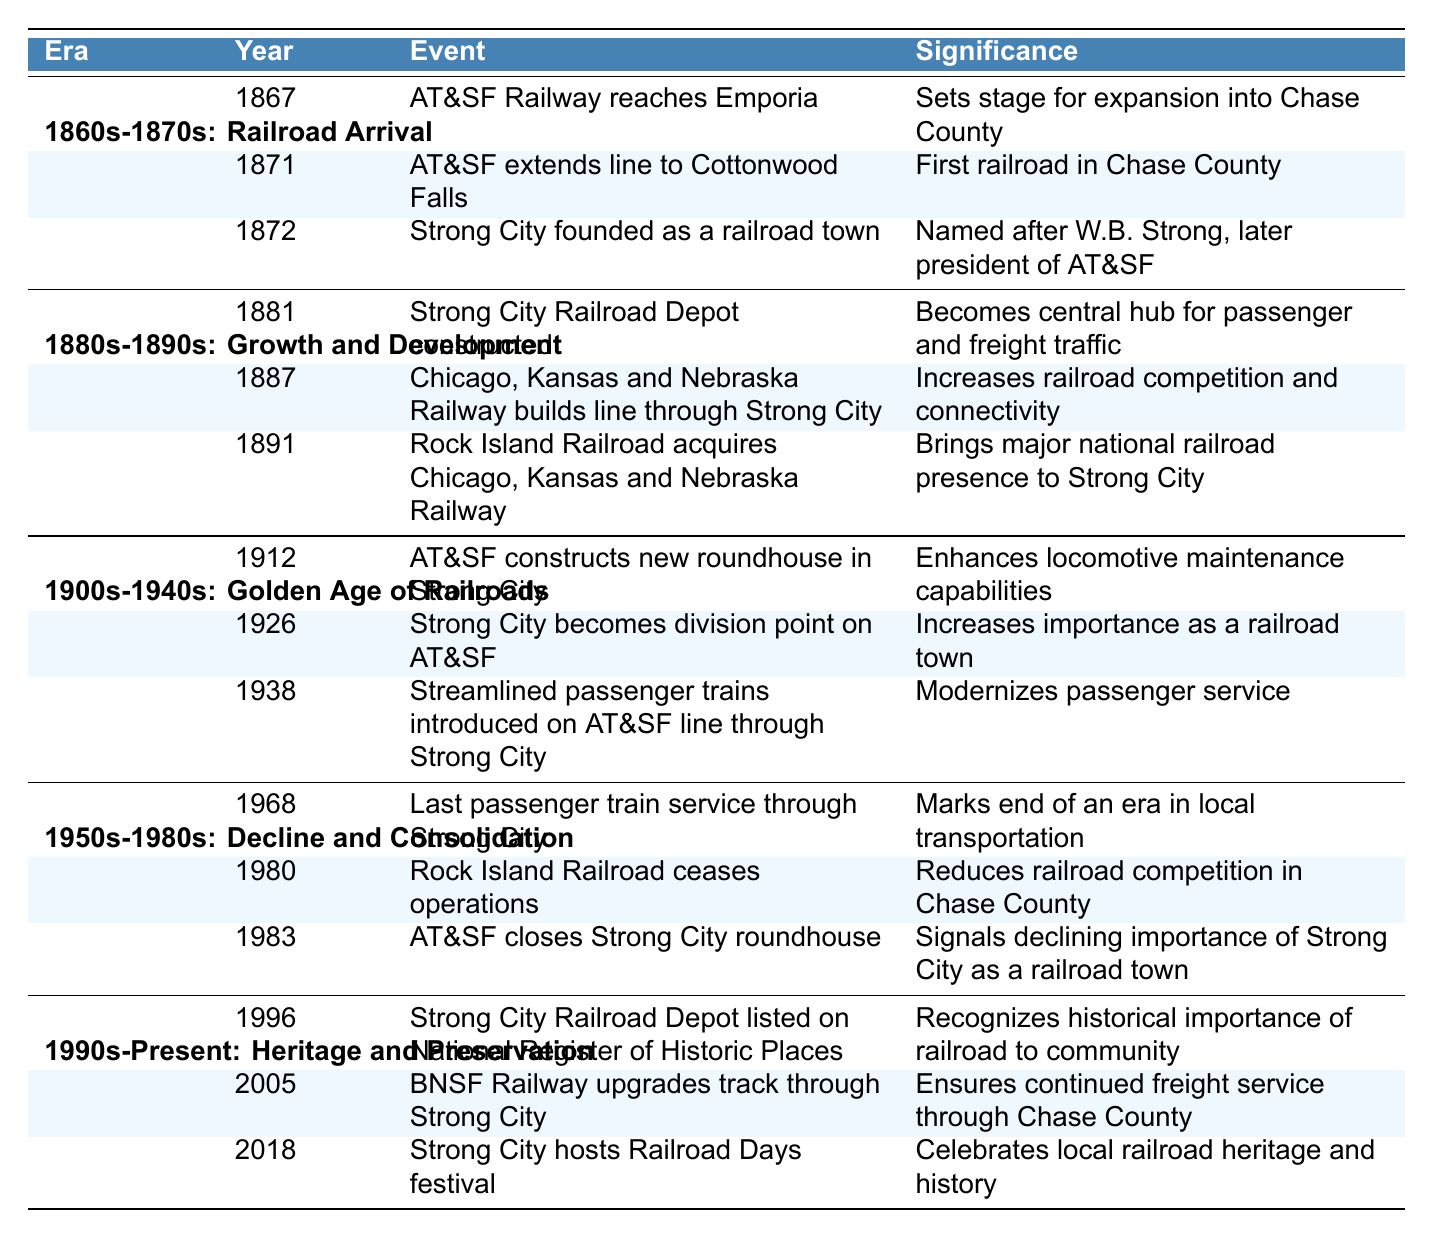What year did Strong City become a division point on the AT&SF? The table shows that Strong City became a division point on the AT&SF in the year 1926.
Answer: 1926 What is the significance of the event in 1871? The event in 1871 is about the AT&SF extending the line to Cottonwood Falls, which is significant because it marks the establishment of the first railroad in Chase County.
Answer: First railroad in Chase County How many significant events are listed in the 1900s-1940s era? By counting the events under the 1900s-1940s era, there are three listed: in 1912, 1926, and 1938.
Answer: 3 Was the last passenger train service through Strong City before or after 1980? The table indicates that the last passenger train service through Strong City occurred in 1968, which is before 1980.
Answer: Before What is the total number of events listed across all eras? The sum of events in each era is: 3 (1860s-1870s) + 3 (1880s-1890s) + 3 (1900s-1940s) + 3 (1950s-1980s) + 3 (1990s-Present) = 15.
Answer: 15 Which era contains the event where Strong City hosted Railroad Days festival? The event of Strong City hosting the Railroad Days festival is found in the 1990s-Present era.
Answer: 1990s-Present What was the significance of the Strong City Railroad Depot being listed on the National Register of Historic Places? The significance is that it recognizes the historical importance of the railroad to the community, as stated in the table.
Answer: Recognizes historical importance How many events mention the closure of railroad facilities? There are two events mentioning closures: the Rock Island Railroad ceasing operations in 1980 and the AT&SF closing the Strong City roundhouse in 1983.
Answer: 2 In which era did the Rock Island Railroad acquire the Chicago, Kansas and Nebraska Railway? The acquisition by the Rock Island Railroad occurred in the 1880s-1890s era, specifically in 1891.
Answer: 1880s-1890s What trends can be observed when comparing the years of significant events in Strong City from 1867 to 2018? The trends indicate an early establishment and growth phase in the 1860s-1890s followed by a golden age in the early 1900s, ending with a decline in the 1960s-1980s, and a preservation phase beginning in the 1990s. Overall, the railroad events transitioned from establishment and expansion to decline and heritage preservation.
Answer: Establishment, decline, preservation 